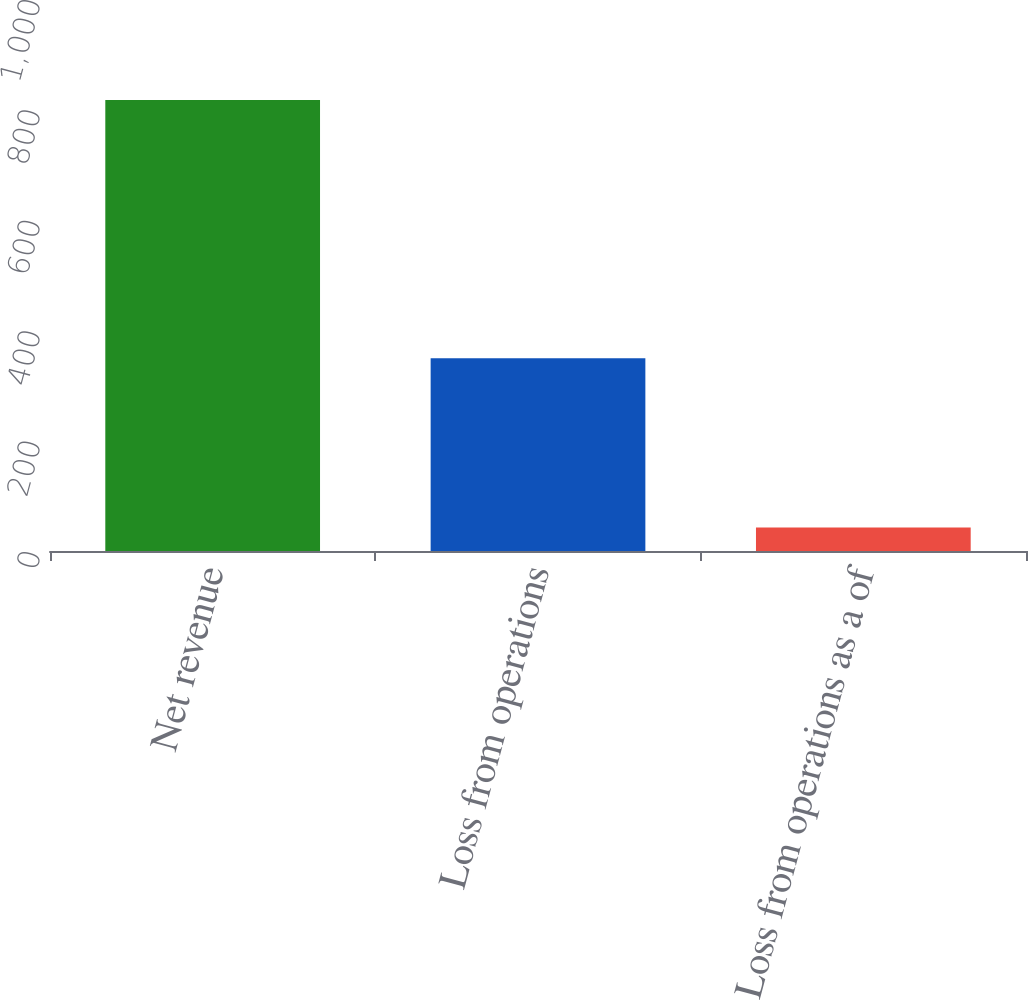Convert chart to OTSL. <chart><loc_0><loc_0><loc_500><loc_500><bar_chart><fcel>Net revenue<fcel>Loss from operations<fcel>Loss from operations as a of<nl><fcel>817<fcel>349<fcel>42.7<nl></chart> 